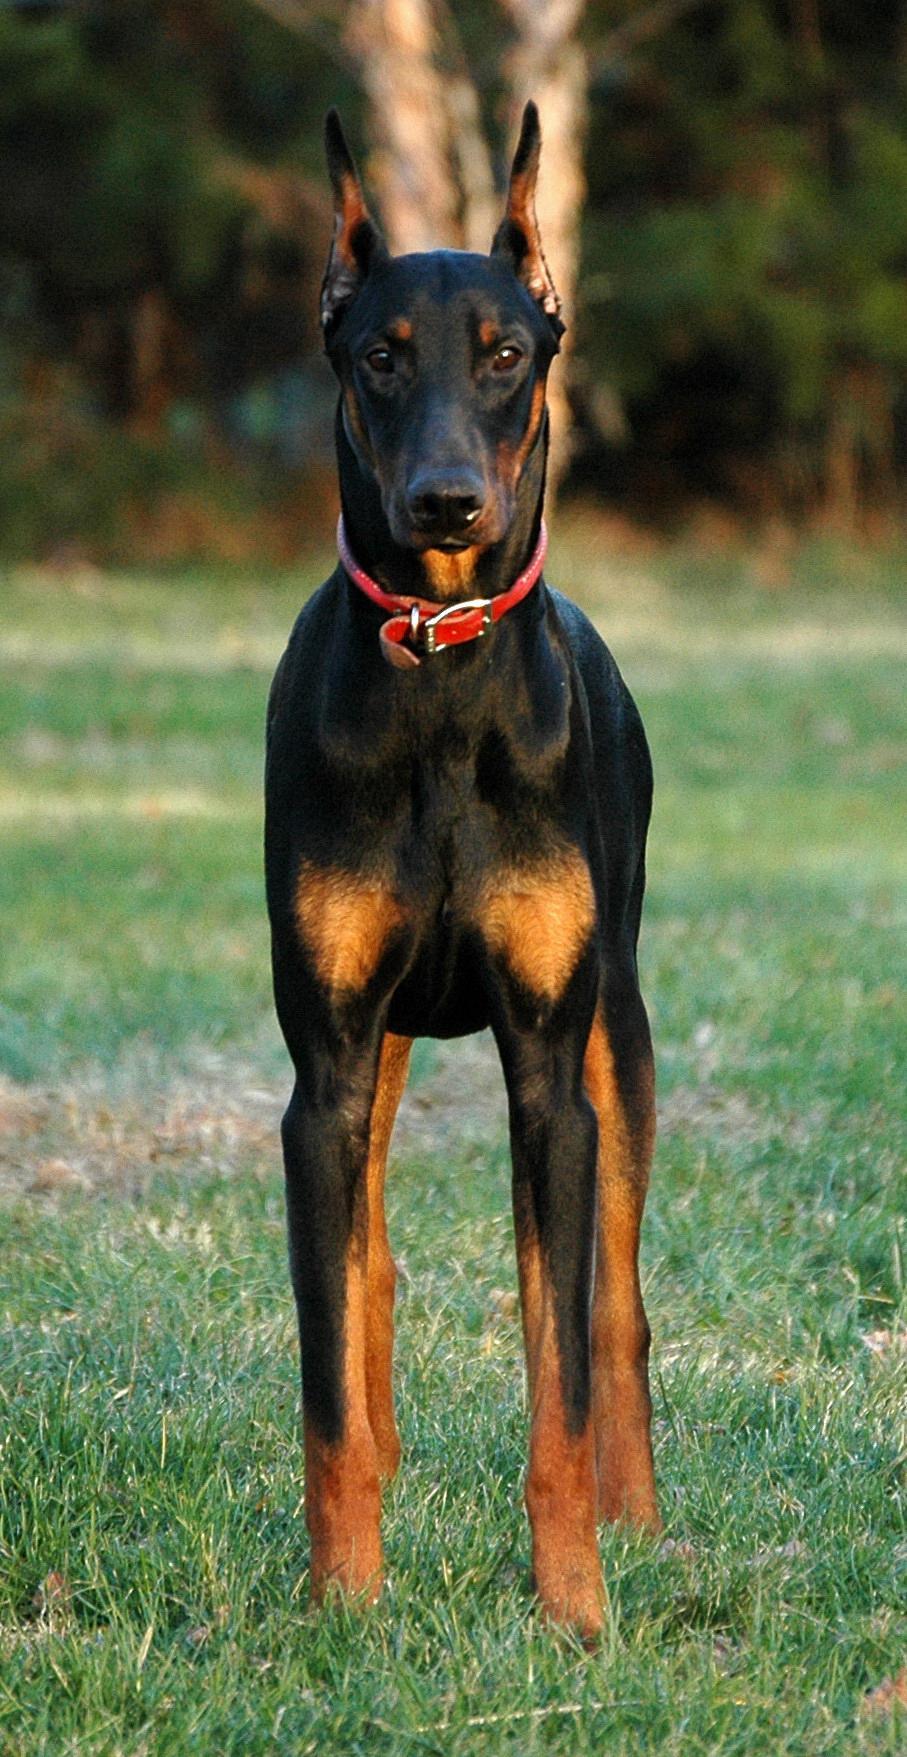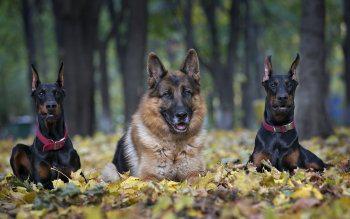The first image is the image on the left, the second image is the image on the right. Considering the images on both sides, is "The right image contains no more than one dog." valid? Answer yes or no. No. The first image is the image on the left, the second image is the image on the right. Assess this claim about the two images: "The right image includes two erect-eared dobermans reclining on fallen leaves, with their bodies turned forward.". Correct or not? Answer yes or no. Yes. 